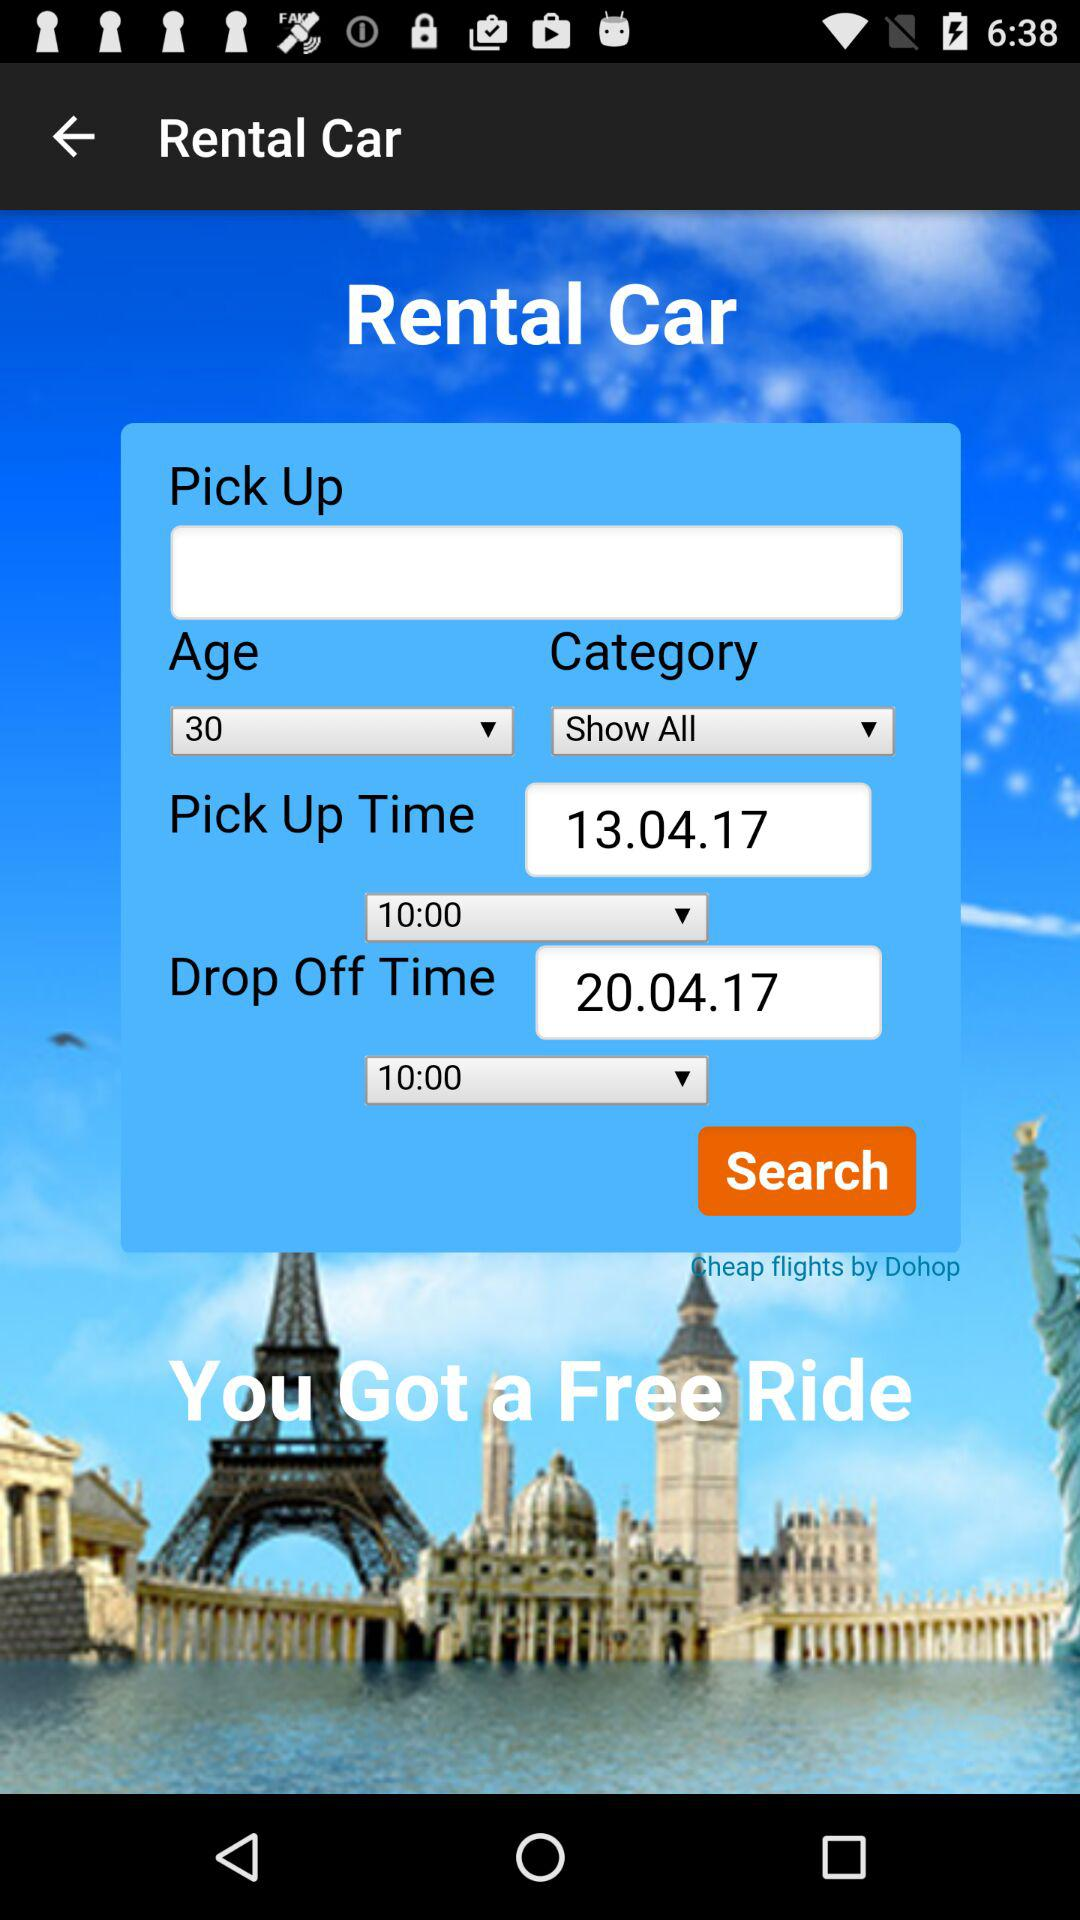What is the drop-off time? The drop-off time is 10:00. 